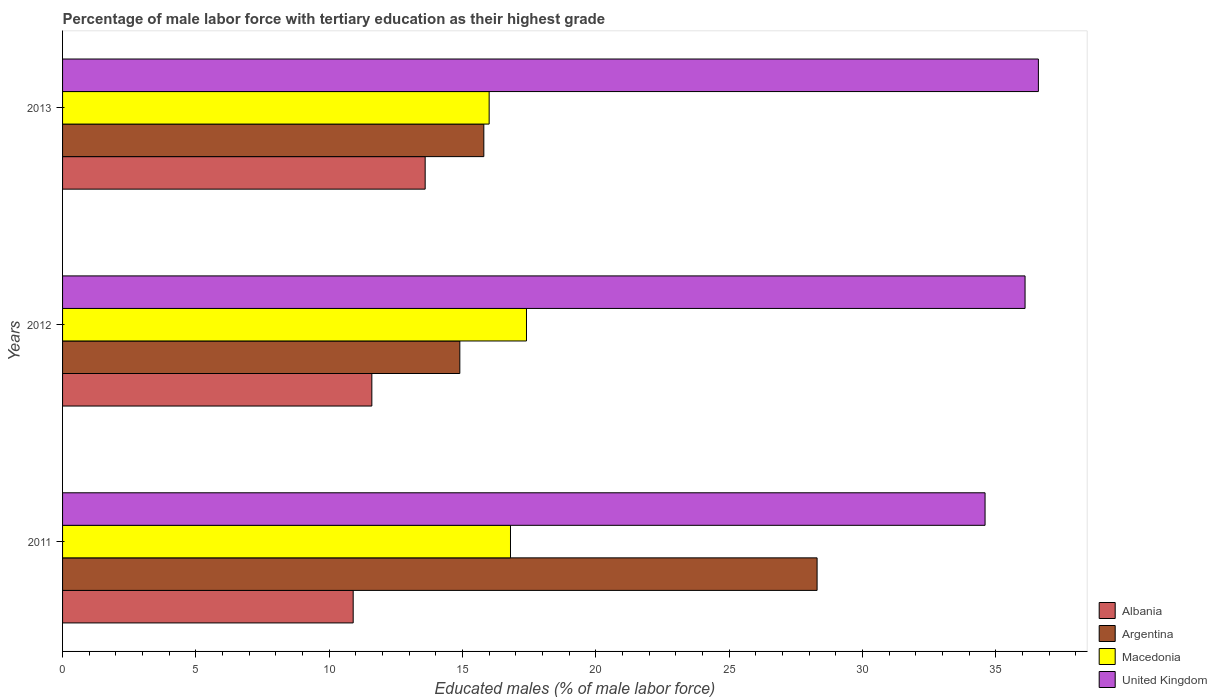How many different coloured bars are there?
Your response must be concise. 4. Are the number of bars per tick equal to the number of legend labels?
Keep it short and to the point. Yes. Are the number of bars on each tick of the Y-axis equal?
Your response must be concise. Yes. How many bars are there on the 2nd tick from the bottom?
Offer a terse response. 4. What is the percentage of male labor force with tertiary education in United Kingdom in 2011?
Provide a short and direct response. 34.6. Across all years, what is the maximum percentage of male labor force with tertiary education in Macedonia?
Give a very brief answer. 17.4. Across all years, what is the minimum percentage of male labor force with tertiary education in United Kingdom?
Offer a very short reply. 34.6. In which year was the percentage of male labor force with tertiary education in United Kingdom minimum?
Provide a succinct answer. 2011. What is the total percentage of male labor force with tertiary education in Argentina in the graph?
Offer a terse response. 59. What is the difference between the percentage of male labor force with tertiary education in Argentina in 2012 and that in 2013?
Make the answer very short. -0.9. What is the difference between the percentage of male labor force with tertiary education in Argentina in 2013 and the percentage of male labor force with tertiary education in Albania in 2012?
Your response must be concise. 4.2. What is the average percentage of male labor force with tertiary education in United Kingdom per year?
Your answer should be very brief. 35.77. In the year 2011, what is the difference between the percentage of male labor force with tertiary education in United Kingdom and percentage of male labor force with tertiary education in Macedonia?
Make the answer very short. 17.8. In how many years, is the percentage of male labor force with tertiary education in Argentina greater than 27 %?
Make the answer very short. 1. What is the ratio of the percentage of male labor force with tertiary education in United Kingdom in 2011 to that in 2013?
Make the answer very short. 0.95. Is the percentage of male labor force with tertiary education in Macedonia in 2012 less than that in 2013?
Your answer should be compact. No. Is it the case that in every year, the sum of the percentage of male labor force with tertiary education in Argentina and percentage of male labor force with tertiary education in United Kingdom is greater than the sum of percentage of male labor force with tertiary education in Macedonia and percentage of male labor force with tertiary education in Albania?
Keep it short and to the point. Yes. What does the 3rd bar from the top in 2011 represents?
Your response must be concise. Argentina. What does the 3rd bar from the bottom in 2011 represents?
Your answer should be very brief. Macedonia. How many bars are there?
Give a very brief answer. 12. Are the values on the major ticks of X-axis written in scientific E-notation?
Give a very brief answer. No. Does the graph contain any zero values?
Provide a short and direct response. No. Does the graph contain grids?
Your response must be concise. No. How are the legend labels stacked?
Your response must be concise. Vertical. What is the title of the graph?
Give a very brief answer. Percentage of male labor force with tertiary education as their highest grade. Does "Europe(all income levels)" appear as one of the legend labels in the graph?
Offer a very short reply. No. What is the label or title of the X-axis?
Your response must be concise. Educated males (% of male labor force). What is the Educated males (% of male labor force) in Albania in 2011?
Offer a very short reply. 10.9. What is the Educated males (% of male labor force) in Argentina in 2011?
Offer a terse response. 28.3. What is the Educated males (% of male labor force) in Macedonia in 2011?
Keep it short and to the point. 16.8. What is the Educated males (% of male labor force) of United Kingdom in 2011?
Provide a short and direct response. 34.6. What is the Educated males (% of male labor force) in Albania in 2012?
Offer a very short reply. 11.6. What is the Educated males (% of male labor force) of Argentina in 2012?
Your answer should be very brief. 14.9. What is the Educated males (% of male labor force) of Macedonia in 2012?
Provide a succinct answer. 17.4. What is the Educated males (% of male labor force) of United Kingdom in 2012?
Provide a succinct answer. 36.1. What is the Educated males (% of male labor force) of Albania in 2013?
Keep it short and to the point. 13.6. What is the Educated males (% of male labor force) in Argentina in 2013?
Give a very brief answer. 15.8. What is the Educated males (% of male labor force) in United Kingdom in 2013?
Your answer should be compact. 36.6. Across all years, what is the maximum Educated males (% of male labor force) in Albania?
Make the answer very short. 13.6. Across all years, what is the maximum Educated males (% of male labor force) of Argentina?
Provide a succinct answer. 28.3. Across all years, what is the maximum Educated males (% of male labor force) in Macedonia?
Ensure brevity in your answer.  17.4. Across all years, what is the maximum Educated males (% of male labor force) in United Kingdom?
Your response must be concise. 36.6. Across all years, what is the minimum Educated males (% of male labor force) of Albania?
Give a very brief answer. 10.9. Across all years, what is the minimum Educated males (% of male labor force) in Argentina?
Provide a short and direct response. 14.9. Across all years, what is the minimum Educated males (% of male labor force) in Macedonia?
Give a very brief answer. 16. Across all years, what is the minimum Educated males (% of male labor force) in United Kingdom?
Provide a succinct answer. 34.6. What is the total Educated males (% of male labor force) of Albania in the graph?
Make the answer very short. 36.1. What is the total Educated males (% of male labor force) of Argentina in the graph?
Your answer should be compact. 59. What is the total Educated males (% of male labor force) of Macedonia in the graph?
Your answer should be very brief. 50.2. What is the total Educated males (% of male labor force) in United Kingdom in the graph?
Provide a succinct answer. 107.3. What is the difference between the Educated males (% of male labor force) in Albania in 2011 and that in 2012?
Your response must be concise. -0.7. What is the difference between the Educated males (% of male labor force) in Macedonia in 2011 and that in 2012?
Provide a succinct answer. -0.6. What is the difference between the Educated males (% of male labor force) in Argentina in 2011 and that in 2013?
Keep it short and to the point. 12.5. What is the difference between the Educated males (% of male labor force) in Macedonia in 2011 and that in 2013?
Your response must be concise. 0.8. What is the difference between the Educated males (% of male labor force) of Albania in 2011 and the Educated males (% of male labor force) of Argentina in 2012?
Make the answer very short. -4. What is the difference between the Educated males (% of male labor force) in Albania in 2011 and the Educated males (% of male labor force) in Macedonia in 2012?
Make the answer very short. -6.5. What is the difference between the Educated males (% of male labor force) in Albania in 2011 and the Educated males (% of male labor force) in United Kingdom in 2012?
Keep it short and to the point. -25.2. What is the difference between the Educated males (% of male labor force) of Argentina in 2011 and the Educated males (% of male labor force) of United Kingdom in 2012?
Your answer should be compact. -7.8. What is the difference between the Educated males (% of male labor force) in Macedonia in 2011 and the Educated males (% of male labor force) in United Kingdom in 2012?
Make the answer very short. -19.3. What is the difference between the Educated males (% of male labor force) in Albania in 2011 and the Educated males (% of male labor force) in Argentina in 2013?
Your answer should be very brief. -4.9. What is the difference between the Educated males (% of male labor force) of Albania in 2011 and the Educated males (% of male labor force) of United Kingdom in 2013?
Keep it short and to the point. -25.7. What is the difference between the Educated males (% of male labor force) in Macedonia in 2011 and the Educated males (% of male labor force) in United Kingdom in 2013?
Offer a very short reply. -19.8. What is the difference between the Educated males (% of male labor force) of Albania in 2012 and the Educated males (% of male labor force) of Argentina in 2013?
Your response must be concise. -4.2. What is the difference between the Educated males (% of male labor force) of Argentina in 2012 and the Educated males (% of male labor force) of Macedonia in 2013?
Keep it short and to the point. -1.1. What is the difference between the Educated males (% of male labor force) in Argentina in 2012 and the Educated males (% of male labor force) in United Kingdom in 2013?
Your answer should be very brief. -21.7. What is the difference between the Educated males (% of male labor force) in Macedonia in 2012 and the Educated males (% of male labor force) in United Kingdom in 2013?
Keep it short and to the point. -19.2. What is the average Educated males (% of male labor force) of Albania per year?
Provide a succinct answer. 12.03. What is the average Educated males (% of male labor force) of Argentina per year?
Your response must be concise. 19.67. What is the average Educated males (% of male labor force) in Macedonia per year?
Keep it short and to the point. 16.73. What is the average Educated males (% of male labor force) of United Kingdom per year?
Your answer should be compact. 35.77. In the year 2011, what is the difference between the Educated males (% of male labor force) of Albania and Educated males (% of male labor force) of Argentina?
Your answer should be very brief. -17.4. In the year 2011, what is the difference between the Educated males (% of male labor force) of Albania and Educated males (% of male labor force) of United Kingdom?
Ensure brevity in your answer.  -23.7. In the year 2011, what is the difference between the Educated males (% of male labor force) of Argentina and Educated males (% of male labor force) of Macedonia?
Provide a short and direct response. 11.5. In the year 2011, what is the difference between the Educated males (% of male labor force) of Argentina and Educated males (% of male labor force) of United Kingdom?
Provide a short and direct response. -6.3. In the year 2011, what is the difference between the Educated males (% of male labor force) of Macedonia and Educated males (% of male labor force) of United Kingdom?
Make the answer very short. -17.8. In the year 2012, what is the difference between the Educated males (% of male labor force) in Albania and Educated males (% of male labor force) in Argentina?
Your answer should be very brief. -3.3. In the year 2012, what is the difference between the Educated males (% of male labor force) of Albania and Educated males (% of male labor force) of United Kingdom?
Make the answer very short. -24.5. In the year 2012, what is the difference between the Educated males (% of male labor force) of Argentina and Educated males (% of male labor force) of United Kingdom?
Offer a very short reply. -21.2. In the year 2012, what is the difference between the Educated males (% of male labor force) of Macedonia and Educated males (% of male labor force) of United Kingdom?
Keep it short and to the point. -18.7. In the year 2013, what is the difference between the Educated males (% of male labor force) in Albania and Educated males (% of male labor force) in Argentina?
Provide a succinct answer. -2.2. In the year 2013, what is the difference between the Educated males (% of male labor force) in Albania and Educated males (% of male labor force) in Macedonia?
Make the answer very short. -2.4. In the year 2013, what is the difference between the Educated males (% of male labor force) of Albania and Educated males (% of male labor force) of United Kingdom?
Offer a very short reply. -23. In the year 2013, what is the difference between the Educated males (% of male labor force) of Argentina and Educated males (% of male labor force) of Macedonia?
Make the answer very short. -0.2. In the year 2013, what is the difference between the Educated males (% of male labor force) of Argentina and Educated males (% of male labor force) of United Kingdom?
Your answer should be compact. -20.8. In the year 2013, what is the difference between the Educated males (% of male labor force) of Macedonia and Educated males (% of male labor force) of United Kingdom?
Offer a very short reply. -20.6. What is the ratio of the Educated males (% of male labor force) of Albania in 2011 to that in 2012?
Your answer should be compact. 0.94. What is the ratio of the Educated males (% of male labor force) in Argentina in 2011 to that in 2012?
Your answer should be very brief. 1.9. What is the ratio of the Educated males (% of male labor force) in Macedonia in 2011 to that in 2012?
Make the answer very short. 0.97. What is the ratio of the Educated males (% of male labor force) of United Kingdom in 2011 to that in 2012?
Provide a short and direct response. 0.96. What is the ratio of the Educated males (% of male labor force) of Albania in 2011 to that in 2013?
Ensure brevity in your answer.  0.8. What is the ratio of the Educated males (% of male labor force) of Argentina in 2011 to that in 2013?
Your response must be concise. 1.79. What is the ratio of the Educated males (% of male labor force) in United Kingdom in 2011 to that in 2013?
Ensure brevity in your answer.  0.95. What is the ratio of the Educated males (% of male labor force) of Albania in 2012 to that in 2013?
Give a very brief answer. 0.85. What is the ratio of the Educated males (% of male labor force) of Argentina in 2012 to that in 2013?
Your answer should be compact. 0.94. What is the ratio of the Educated males (% of male labor force) of Macedonia in 2012 to that in 2013?
Make the answer very short. 1.09. What is the ratio of the Educated males (% of male labor force) of United Kingdom in 2012 to that in 2013?
Give a very brief answer. 0.99. What is the difference between the highest and the second highest Educated males (% of male labor force) of Macedonia?
Your answer should be very brief. 0.6. What is the difference between the highest and the lowest Educated males (% of male labor force) in Argentina?
Give a very brief answer. 13.4. What is the difference between the highest and the lowest Educated males (% of male labor force) of Macedonia?
Keep it short and to the point. 1.4. What is the difference between the highest and the lowest Educated males (% of male labor force) of United Kingdom?
Offer a very short reply. 2. 